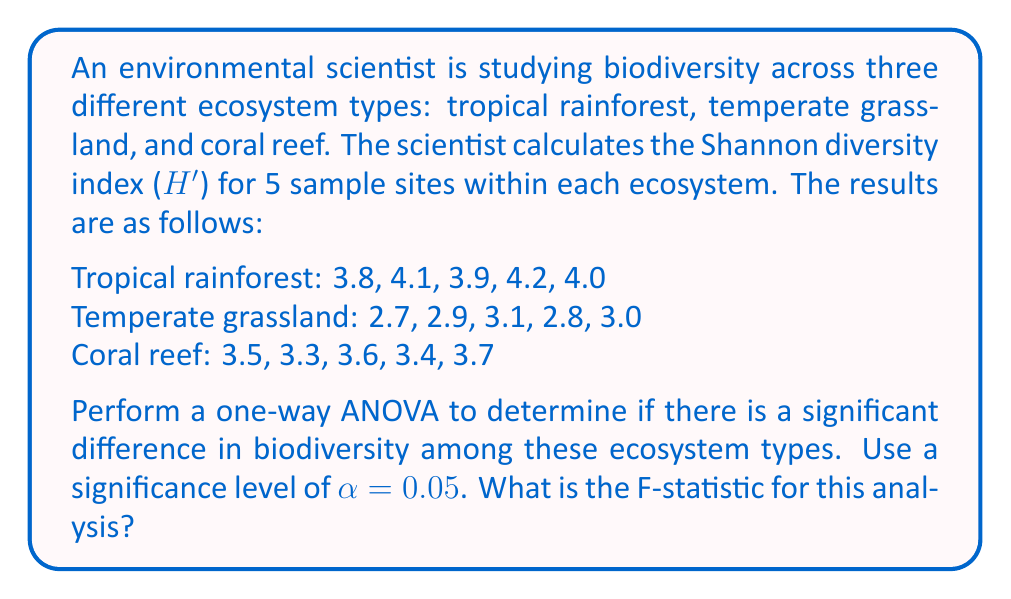Can you solve this math problem? To perform a one-way ANOVA, we need to follow these steps:

1. Calculate the mean for each group and the overall mean:
   Tropical rainforest mean: $\bar{x}_1 = \frac{3.8 + 4.1 + 3.9 + 4.2 + 4.0}{5} = 4.0$
   Temperate grassland mean: $\bar{x}_2 = \frac{2.7 + 2.9 + 3.1 + 2.8 + 3.0}{5} = 2.9$
   Coral reef mean: $\bar{x}_3 = \frac{3.5 + 3.3 + 3.6 + 3.4 + 3.7}{5} = 3.5$
   Overall mean: $\bar{x} = \frac{4.0 + 2.9 + 3.5}{3} = 3.47$

2. Calculate the Sum of Squares Between groups (SSB):
   $$SSB = \sum_{i=1}^k n_i(\bar{x}_i - \bar{x})^2$$
   where $k$ is the number of groups and $n_i$ is the number of observations in each group.
   $$SSB = 5(4.0 - 3.47)^2 + 5(2.9 - 3.47)^2 + 5(3.5 - 3.47)^2 = 3.0133$$

3. Calculate the Sum of Squares Within groups (SSW):
   $$SSW = \sum_{i=1}^k \sum_{j=1}^{n_i} (x_{ij} - \bar{x}_i)^2$$
   Tropical rainforest: $(3.8 - 4.0)^2 + (4.1 - 4.0)^2 + (3.9 - 4.0)^2 + (4.2 - 4.0)^2 + (4.0 - 4.0)^2 = 0.13$
   Temperate grassland: $(2.7 - 2.9)^2 + (2.9 - 2.9)^2 + (3.1 - 2.9)^2 + (2.8 - 2.9)^2 + (3.0 - 2.9)^2 = 0.13$
   Coral reef: $(3.5 - 3.5)^2 + (3.3 - 3.5)^2 + (3.6 - 3.5)^2 + (3.4 - 3.5)^2 + (3.7 - 3.5)^2 = 0.13$
   $$SSW = 0.13 + 0.13 + 0.13 = 0.39$$

4. Calculate the degrees of freedom:
   Between groups: $df_B = k - 1 = 3 - 1 = 2$
   Within groups: $df_W = N - k = 15 - 3 = 12$
   where $N$ is the total number of observations.

5. Calculate the Mean Square Between (MSB) and Mean Square Within (MSW):
   $$MSB = \frac{SSB}{df_B} = \frac{3.0133}{2} = 1.50665$$
   $$MSW = \frac{SSW}{df_W} = \frac{0.39}{12} = 0.0325$$

6. Calculate the F-statistic:
   $$F = \frac{MSB}{MSW} = \frac{1.50665}{0.0325} = 46.36$$

The F-statistic for this analysis is 46.36.
Answer: 46.36 